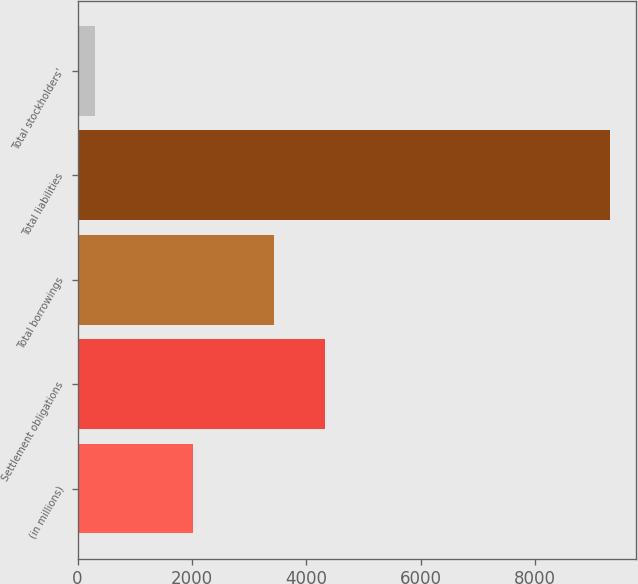<chart> <loc_0><loc_0><loc_500><loc_500><bar_chart><fcel>(in millions)<fcel>Settlement obligations<fcel>Total borrowings<fcel>Total liabilities<fcel>Total stockholders'<nl><fcel>2018<fcel>4333.38<fcel>3433.7<fcel>9306.6<fcel>309.8<nl></chart> 